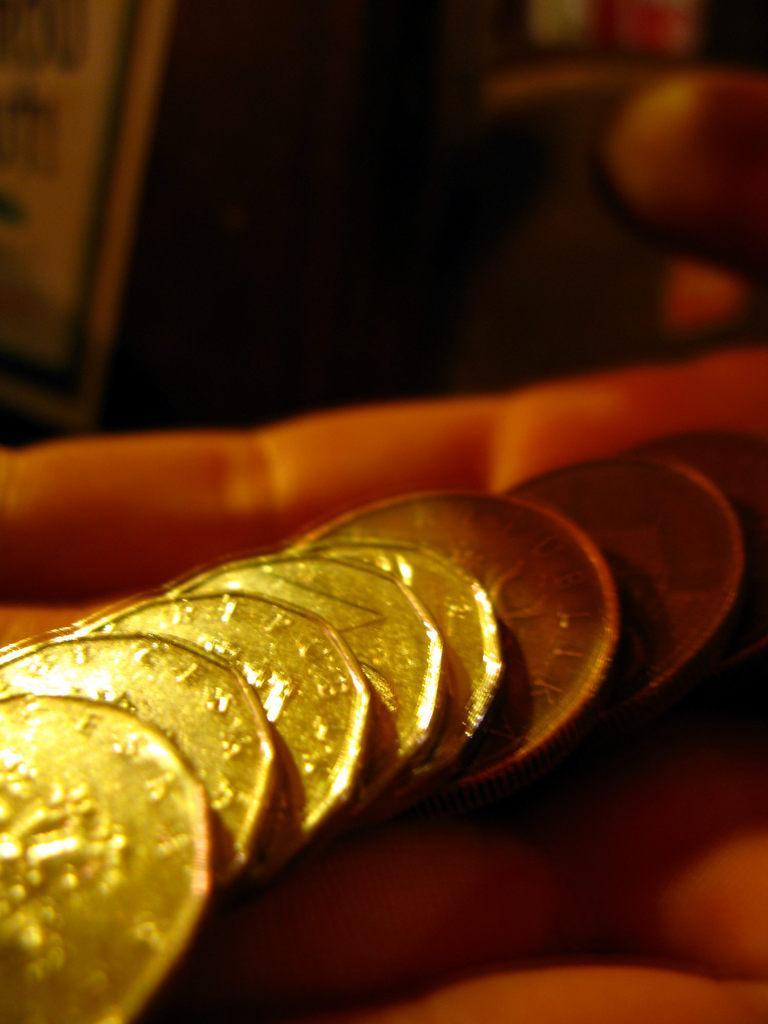How would you summarize this image in a sentence or two? In this picture we can see coins on hand of a person. In the background of the image it is blurry. 